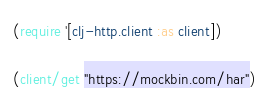<code> <loc_0><loc_0><loc_500><loc_500><_Clojure_>(require '[clj-http.client :as client])

(client/get "https://mockbin.com/har")
</code> 